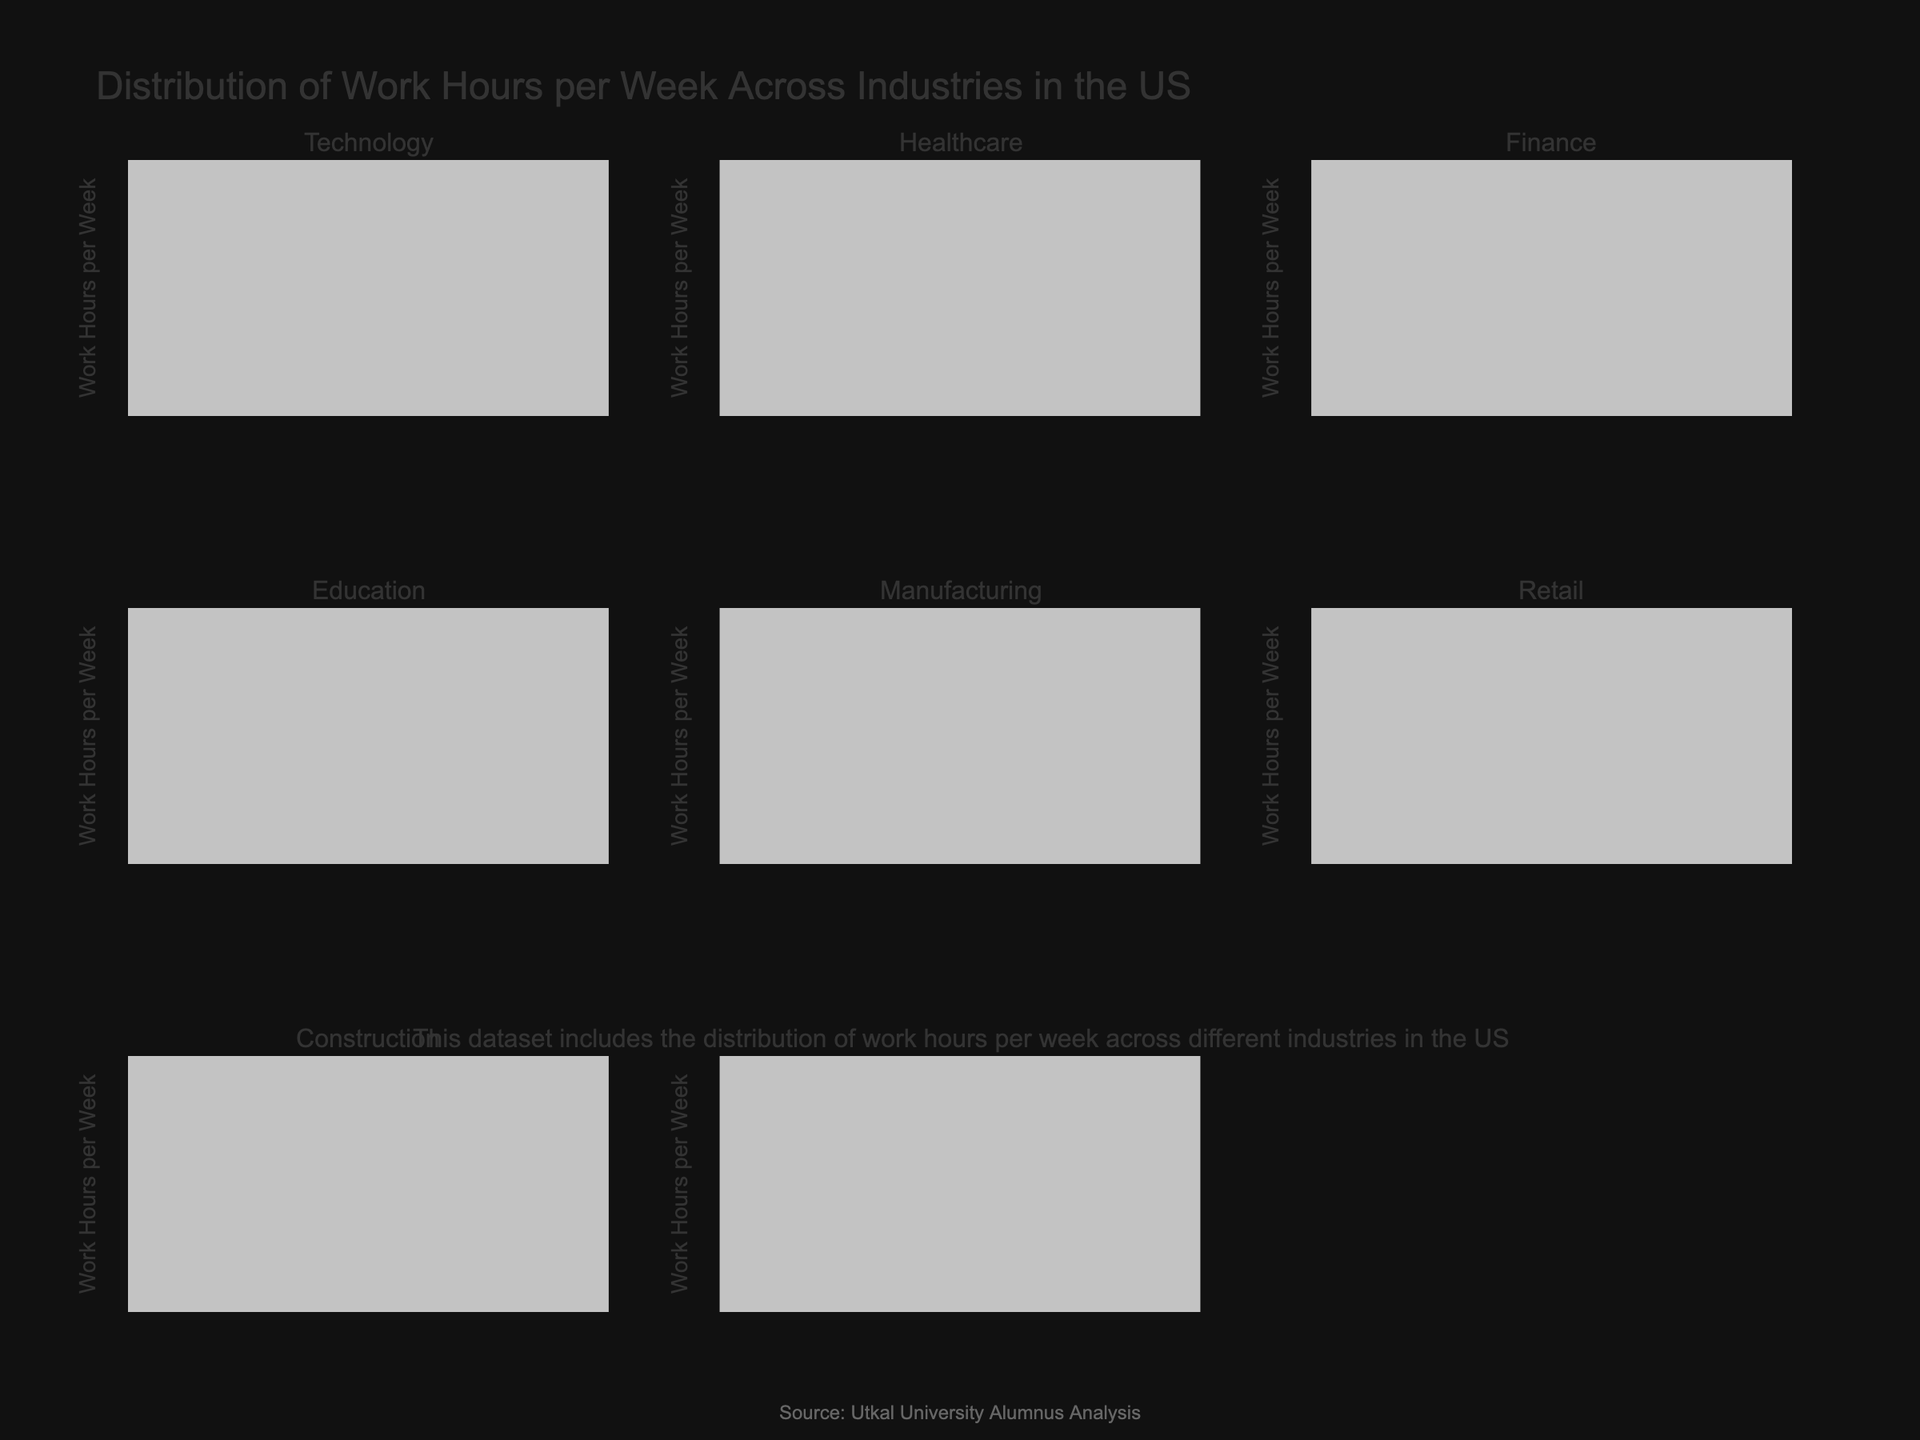What is the title of the figure? The title is typically placed at the top of the figure. In this case, it is specified in the layout of the code.
Answer: Distribution of Work Hours per Week Across Industries in the US Which industry has the highest median work hours per week? Look at the center line in each violin plot which represents the median. Identify the industry where this line is the highest.
Answer: Finance Which industry appears to have the widest range of work hours per week? The range is indicated by the spread of the violin plot from top to bottom. The widest span represents the widest range.
Answer: Retail How do the median work hours in Technology compare to those in Healthcare? Locate the median line (middle line) in the Technology and Healthcare violin plots and compare their positions.
Answer: Technology has higher median hours What is the approximate median work hours per week in the Education industry? Find the middle line of the violin plot for the Education industry and see where it falls on the y-axis.
Answer: 37.5 hours Are there any industries where the work hours per week do not exceed 50? Examine each violin plot and check if the topmost point goes beyond 50 hours. Note those which do not.
Answer: Education, Retail Which industry has the least variation in work hours per week? The least variation is indicated by the narrowest violin plot. Identify which plot has the least spread.
Answer: Manufacturing What is the difference in the median work hours per week between Construction and Retail? Identify the median work hours of both industries from their respective plots and subtract the median of Retail from that of Construction.
Answer: 15 hours Which industry has the lowest lower quartile (25th percentile) of work hours? The lower bound of the box plot within the violin represents the 25th percentile. Check each plot manually if necessary.
Answer: Retail How consistent are the work hours per week in the Healthcare industry compared to Technology? Compare the spread (width) and the length of the violin plots, considering the box plot for both industries. Based on that, we can assess consistency.
Answer: Healthcare is less consistent 